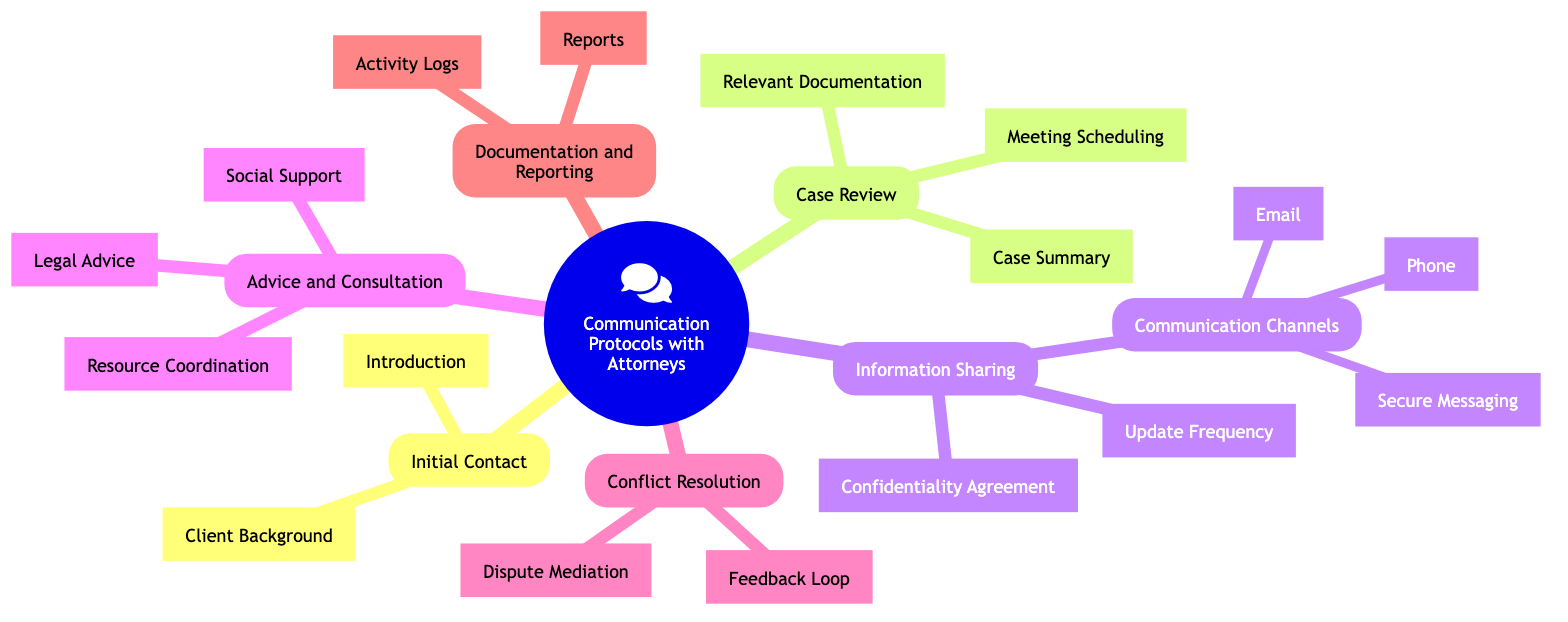What is the main method for formal communication? In the "Information Sharing" section, the sub-node under "Communication Channels" specifically mentions "Email" as the main method for formal communication.
Answer: Email How many nodes are in the "Advice and Consultation" section? In the "Advice and Consultation" section, there are three nodes listed: "Legal Advice," "Social Support," and "Resource Coordination." Counting these gives a total of three nodes.
Answer: 3 What comes after the "Initial Contact" node? The node directly following "Initial Contact" in the hierarchy of the mind map is "Case Review." This indicates that after making initial contact, the next step is to review the case.
Answer: Case Review Which section includes the "Feedback Loop"? The "Feedback Loop" is found in the "Conflict Resolution" section. This indicates that it is part of the strategies or processes for addressing any disagreements that arise.
Answer: Conflict Resolution What is the purpose of "Activity Logs"? In the "Documentation and Reporting" section, "Activity Logs" are listed as a method to maintain records of communications and actions taken, indicating their purpose is to track interactions and interventions.
Answer: Maintain logs What is the first step in the communication protocol? The first step in the communication protocol, as shown in the diagram, is "Initial Contact," which indicates the starting point for communication with attorneys.
Answer: Initial Contact Which communication method is used for urgent matters? The diagram specifies "Phone" in the "Information Sharing" section under "Communication Channels" as the method used for urgent matters.
Answer: Phone How many total sections are there in the mind map? There are a total of six sections in the mind map: "Initial Contact," "Case Review," "Information Sharing," "Advice and Consultation," "Conflict Resolution," and "Documentation and Reporting." Thus, counting these gives a total of six sections.
Answer: 6 